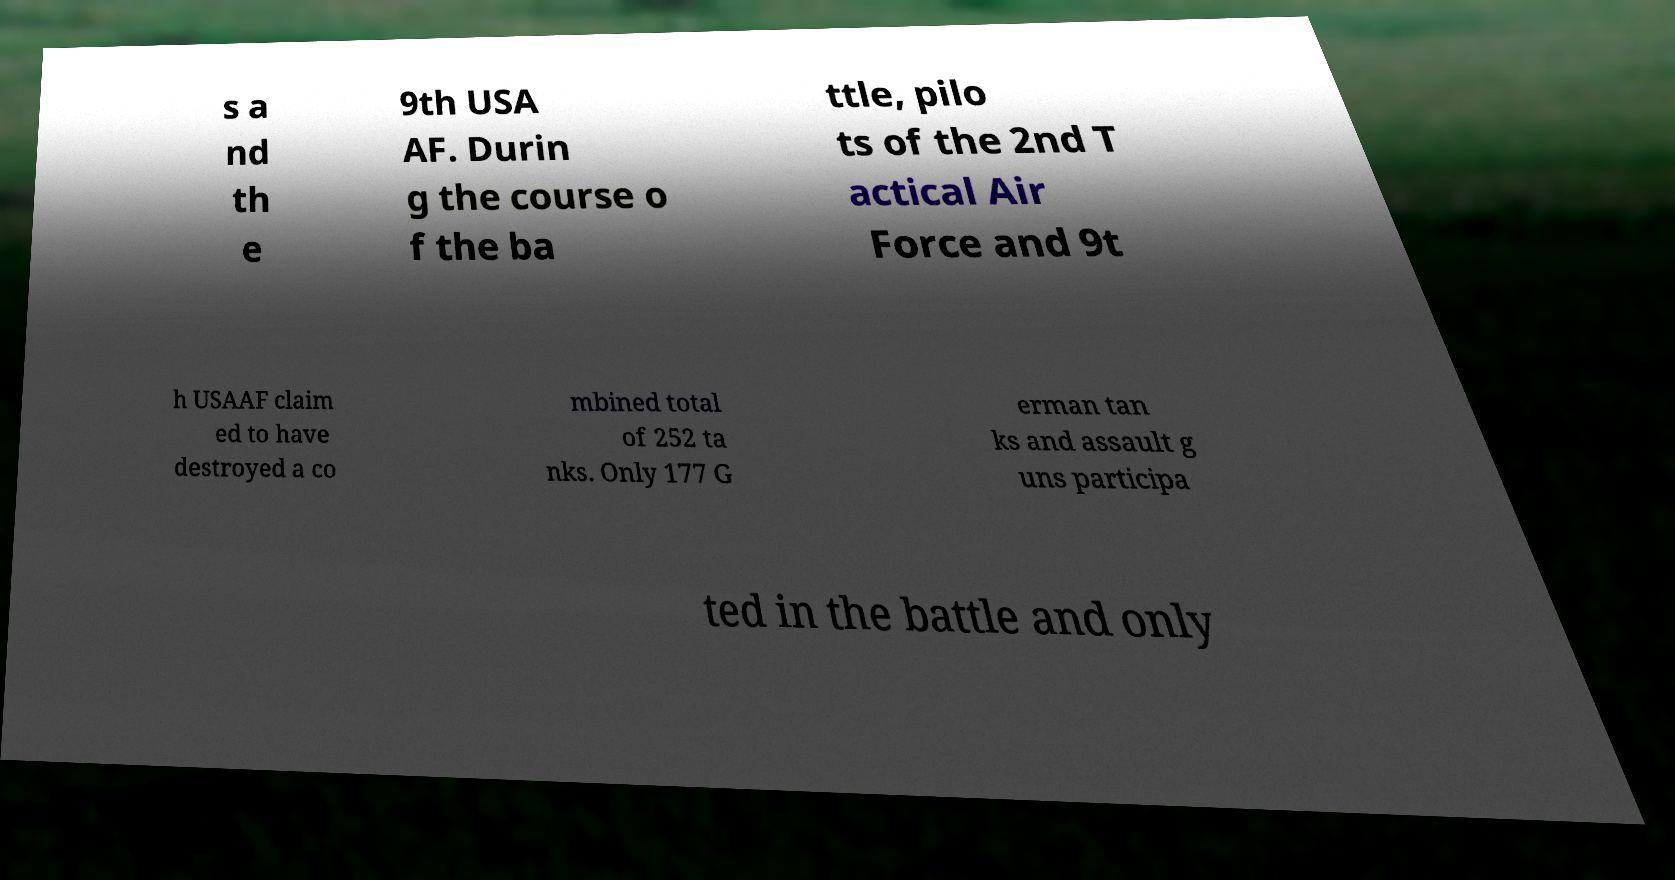There's text embedded in this image that I need extracted. Can you transcribe it verbatim? s a nd th e 9th USA AF. Durin g the course o f the ba ttle, pilo ts of the 2nd T actical Air Force and 9t h USAAF claim ed to have destroyed a co mbined total of 252 ta nks. Only 177 G erman tan ks and assault g uns participa ted in the battle and only 